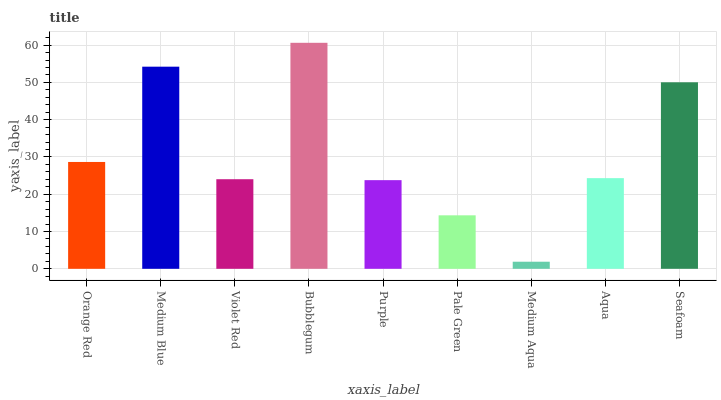Is Medium Aqua the minimum?
Answer yes or no. Yes. Is Bubblegum the maximum?
Answer yes or no. Yes. Is Medium Blue the minimum?
Answer yes or no. No. Is Medium Blue the maximum?
Answer yes or no. No. Is Medium Blue greater than Orange Red?
Answer yes or no. Yes. Is Orange Red less than Medium Blue?
Answer yes or no. Yes. Is Orange Red greater than Medium Blue?
Answer yes or no. No. Is Medium Blue less than Orange Red?
Answer yes or no. No. Is Aqua the high median?
Answer yes or no. Yes. Is Aqua the low median?
Answer yes or no. Yes. Is Purple the high median?
Answer yes or no. No. Is Violet Red the low median?
Answer yes or no. No. 